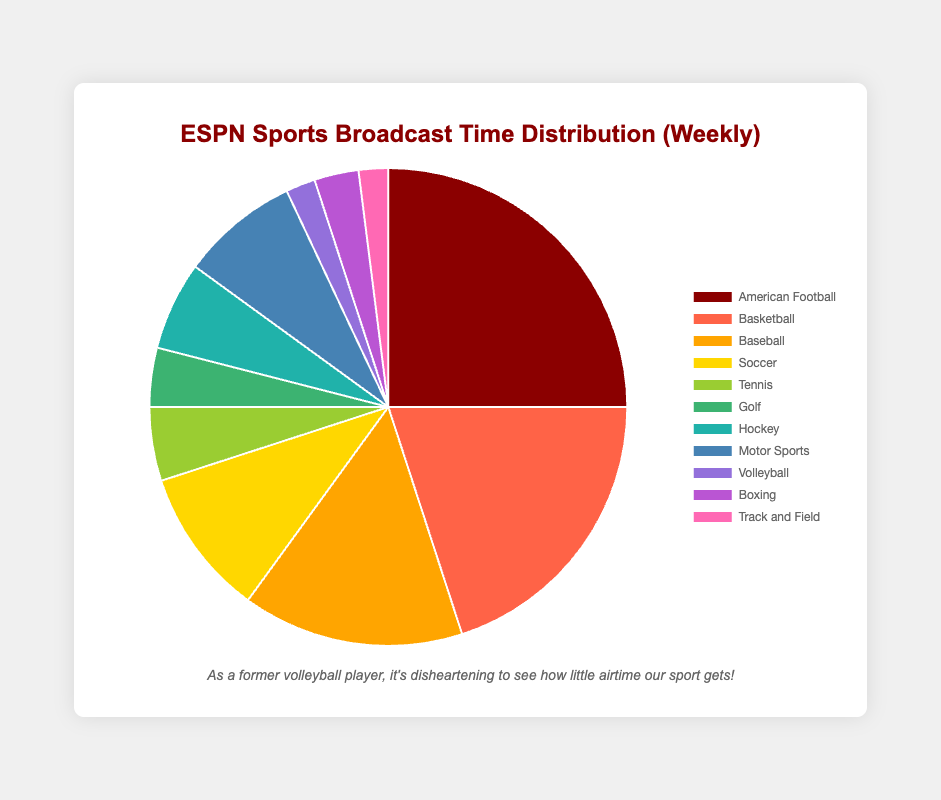What is the total broadcast time allocated to team sports? First, identify which sports are considered team sports. Team sports in the data are American Football (25 hours), Basketball (20 hours), Baseball (15 hours), Soccer (10 hours), Hockey (6 hours), and Volleyball (2 hours). Add these times together: 25 + 20 + 15 + 10 + 6 + 2 = 78.
Answer: 78 hours Which sport gets the most broadcast time and how much time does it get? Look at the pie chart data and find the sport with the largest value. American Football has the highest broadcast time with 25 hours.
Answer: American Football, 25 hours How many sports have a broadcast time of 10 hours or more? Scan the data and count the entries with broadcast times equal to or greater than 10 hours. The sports are American Football (25), Basketball (20), Baseball (15), and Soccer (10). This gives us 4 sports.
Answer: 4 sports What is the average broadcast time per sport? First, calculate the total broadcast time by summing all values: 25 + 20 + 15 + 10 + 5 + 4 + 6 + 8 + 2 + 3 + 2 = 100. Then divide this by the number of sports (11). The average broadcast time is 100 / 11 ≈ 9.09 hours.
Answer: ≈ 9.09 hours By how many hours does basketball's broadcast time exceed tennis's broadcast time? Subtract the broadcast time of Tennis (5 hours) from that of Basketball (20 hours). 20 - 5 = 15 hours.
Answer: 15 hours Compare the combined broadcast time of soccer and motor sports with that of basketball. Which is higher, and by how much? First, add the broadcast times for Soccer (10 hours) and Motor Sports (8 hours): 10 + 8 = 18. Then compare this to Basketball's broadcast time (20 hours). Basketball has 20 - 18 = 2 more hours.
Answer: Basketball, 2 hours more What percentage of the total broadcast time is allocated to volleyball? The total broadcast time is 100 hours. Volleyball has 2 hours of broadcast time. The percentage is (2 / 100) * 100% = 2%.
Answer: 2% What is the difference in broadcast time between the sport with the most time and the sport with the least time? The sport with the most time is American Football (25 hours), and the sports with the least time are Volleyball and Track and Field (2 hours each). The difference is 25 - 2 = 23 hours.
Answer: 23 hours What is the combined broadcast time of all non-team sports? Identify the non-team sports, which are Tennis (5), Golf (4), Motor Sports (8), Boxing (3), Track and Field (2). Add these together: 5 + 4 + 8 + 3 + 2 = 22 hours.
Answer: 22 hours 